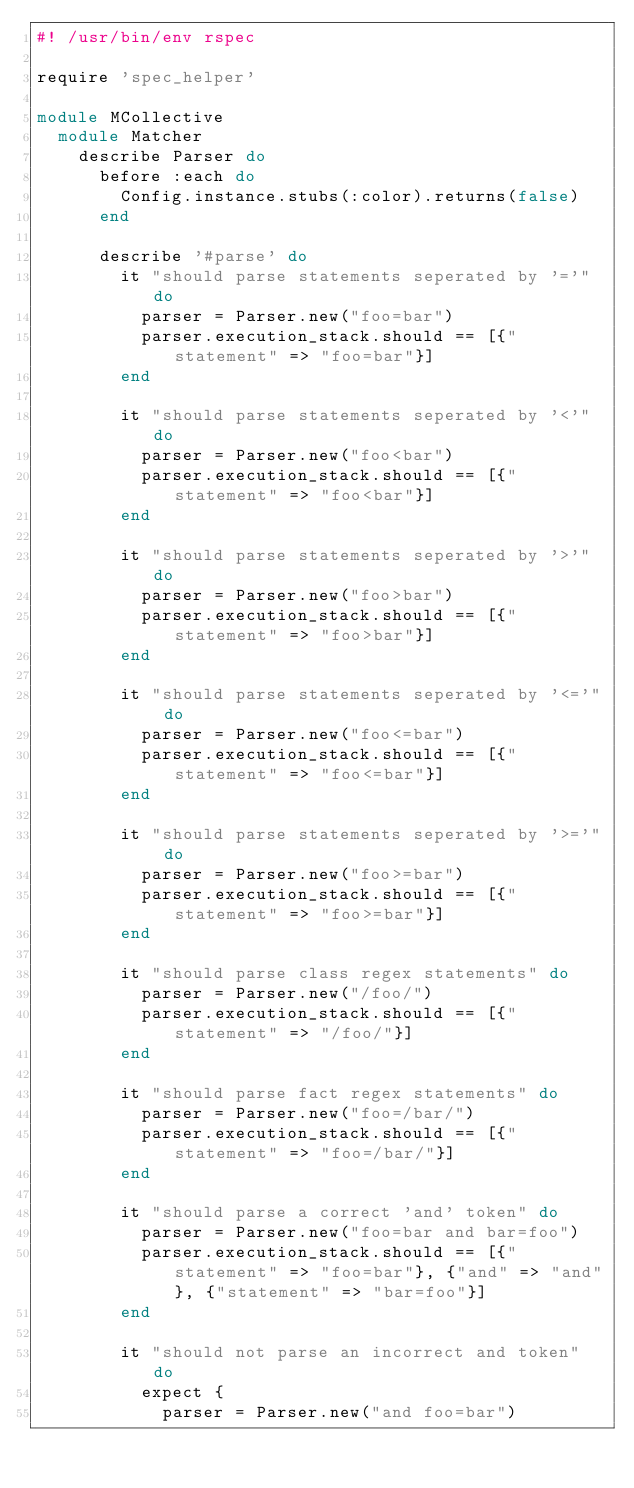<code> <loc_0><loc_0><loc_500><loc_500><_Ruby_>#! /usr/bin/env rspec

require 'spec_helper'

module MCollective
  module Matcher
    describe Parser do
      before :each do
        Config.instance.stubs(:color).returns(false)
      end

      describe '#parse' do
        it "should parse statements seperated by '='" do
          parser = Parser.new("foo=bar")
          parser.execution_stack.should == [{"statement" => "foo=bar"}]
        end

        it "should parse statements seperated by '<'" do
          parser = Parser.new("foo<bar")
          parser.execution_stack.should == [{"statement" => "foo<bar"}]
        end

        it "should parse statements seperated by '>'" do
          parser = Parser.new("foo>bar")
          parser.execution_stack.should == [{"statement" => "foo>bar"}]
        end

        it "should parse statements seperated by '<='" do
          parser = Parser.new("foo<=bar")
          parser.execution_stack.should == [{"statement" => "foo<=bar"}]
        end

        it "should parse statements seperated by '>='" do
          parser = Parser.new("foo>=bar")
          parser.execution_stack.should == [{"statement" => "foo>=bar"}]
        end

        it "should parse class regex statements" do
          parser = Parser.new("/foo/")
          parser.execution_stack.should == [{"statement" => "/foo/"}]
        end

        it "should parse fact regex statements" do
          parser = Parser.new("foo=/bar/")
          parser.execution_stack.should == [{"statement" => "foo=/bar/"}]
        end

        it "should parse a correct 'and' token" do
          parser = Parser.new("foo=bar and bar=foo")
          parser.execution_stack.should == [{"statement" => "foo=bar"}, {"and" => "and"}, {"statement" => "bar=foo"}]
        end

        it "should not parse an incorrect and token" do
          expect {
            parser = Parser.new("and foo=bar")</code> 